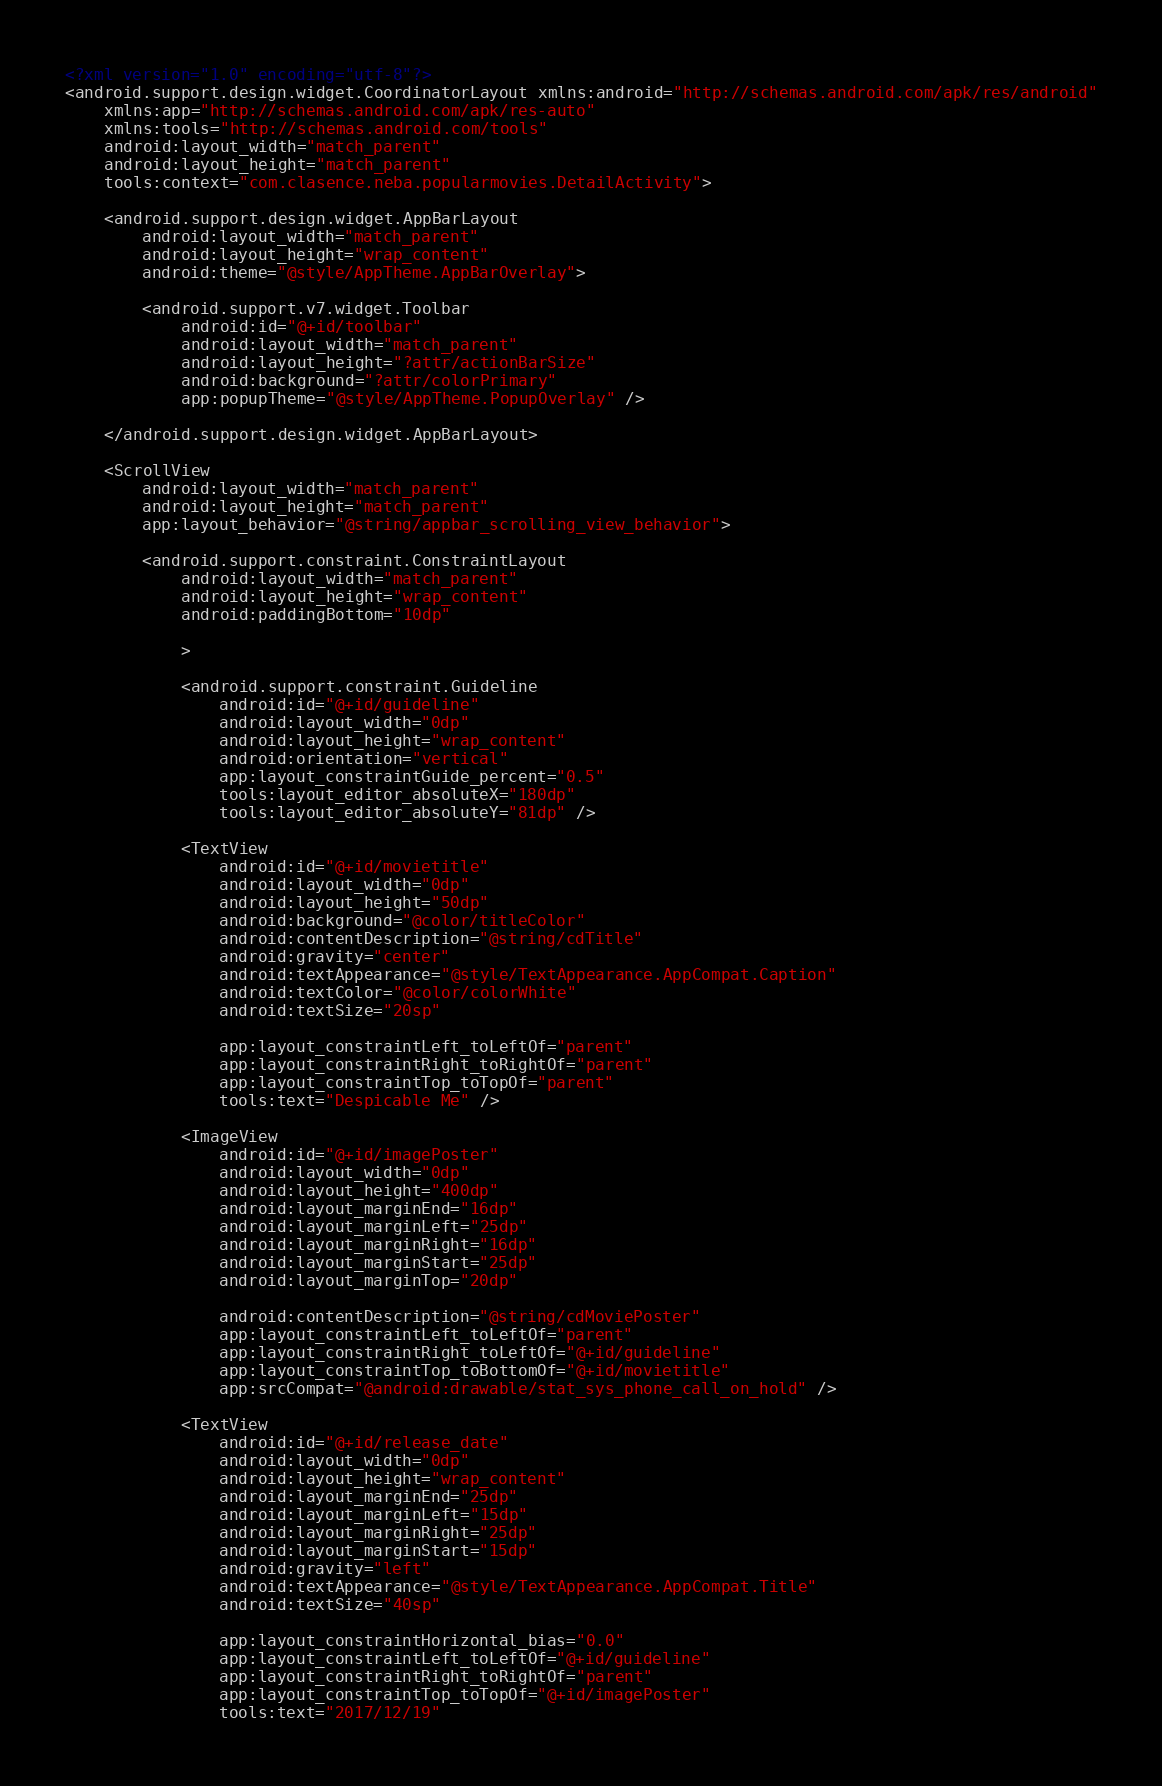Convert code to text. <code><loc_0><loc_0><loc_500><loc_500><_XML_><?xml version="1.0" encoding="utf-8"?>
<android.support.design.widget.CoordinatorLayout xmlns:android="http://schemas.android.com/apk/res/android"
    xmlns:app="http://schemas.android.com/apk/res-auto"
    xmlns:tools="http://schemas.android.com/tools"
    android:layout_width="match_parent"
    android:layout_height="match_parent"
    tools:context="com.clasence.neba.popularmovies.DetailActivity">

    <android.support.design.widget.AppBarLayout
        android:layout_width="match_parent"
        android:layout_height="wrap_content"
        android:theme="@style/AppTheme.AppBarOverlay">

        <android.support.v7.widget.Toolbar
            android:id="@+id/toolbar"
            android:layout_width="match_parent"
            android:layout_height="?attr/actionBarSize"
            android:background="?attr/colorPrimary"
            app:popupTheme="@style/AppTheme.PopupOverlay" />

    </android.support.design.widget.AppBarLayout>

    <ScrollView
        android:layout_width="match_parent"
        android:layout_height="match_parent"
        app:layout_behavior="@string/appbar_scrolling_view_behavior">

        <android.support.constraint.ConstraintLayout
            android:layout_width="match_parent"
            android:layout_height="wrap_content"
            android:paddingBottom="10dp"

            >

            <android.support.constraint.Guideline
                android:id="@+id/guideline"
                android:layout_width="0dp"
                android:layout_height="wrap_content"
                android:orientation="vertical"
                app:layout_constraintGuide_percent="0.5"
                tools:layout_editor_absoluteX="180dp"
                tools:layout_editor_absoluteY="81dp" />

            <TextView
                android:id="@+id/movietitle"
                android:layout_width="0dp"
                android:layout_height="50dp"
                android:background="@color/titleColor"
                android:contentDescription="@string/cdTitle"
                android:gravity="center"
                android:textAppearance="@style/TextAppearance.AppCompat.Caption"
                android:textColor="@color/colorWhite"
                android:textSize="20sp"

                app:layout_constraintLeft_toLeftOf="parent"
                app:layout_constraintRight_toRightOf="parent"
                app:layout_constraintTop_toTopOf="parent"
                tools:text="Despicable Me" />

            <ImageView
                android:id="@+id/imagePoster"
                android:layout_width="0dp"
                android:layout_height="400dp"
                android:layout_marginEnd="16dp"
                android:layout_marginLeft="25dp"
                android:layout_marginRight="16dp"
                android:layout_marginStart="25dp"
                android:layout_marginTop="20dp"

                android:contentDescription="@string/cdMoviePoster"
                app:layout_constraintLeft_toLeftOf="parent"
                app:layout_constraintRight_toLeftOf="@+id/guideline"
                app:layout_constraintTop_toBottomOf="@+id/movietitle"
                app:srcCompat="@android:drawable/stat_sys_phone_call_on_hold" />

            <TextView
                android:id="@+id/release_date"
                android:layout_width="0dp"
                android:layout_height="wrap_content"
                android:layout_marginEnd="25dp"
                android:layout_marginLeft="15dp"
                android:layout_marginRight="25dp"
                android:layout_marginStart="15dp"
                android:gravity="left"
                android:textAppearance="@style/TextAppearance.AppCompat.Title"
                android:textSize="40sp"

                app:layout_constraintHorizontal_bias="0.0"
                app:layout_constraintLeft_toLeftOf="@+id/guideline"
                app:layout_constraintRight_toRightOf="parent"
                app:layout_constraintTop_toTopOf="@+id/imagePoster"
                tools:text="2017/12/19"</code> 